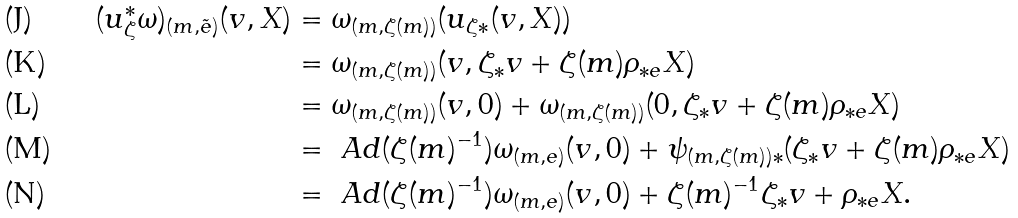<formula> <loc_0><loc_0><loc_500><loc_500>( u _ { \zeta } ^ { * } \omega ) _ { ( m , \tilde { e } ) } ( v , X ) & = \omega _ { ( m , \zeta ( m ) ) } ( u _ { \zeta * } ( v , X ) ) \\ & = \omega _ { ( m , \zeta ( m ) ) } ( v , \zeta _ { * } v + \zeta ( m ) \rho _ { * e } X ) \\ & = \omega _ { ( m , \zeta ( m ) ) } ( v , 0 ) + \omega _ { ( m , \zeta ( m ) ) } ( 0 , \zeta _ { * } v + \zeta ( m ) \rho _ { * e } X ) \\ & = \ A d ( \zeta ( m ) ^ { - 1 } ) \omega _ { ( m , e ) } ( v , 0 ) + \psi _ { ( m , \zeta ( m ) ) * } ( \zeta _ { * } v + \zeta ( m ) \rho _ { * e } X ) \\ & = \ A d ( \zeta ( m ) ^ { - 1 } ) \omega _ { ( m , e ) } ( v , 0 ) + \zeta ( m ) ^ { - 1 } \zeta _ { * } v + \rho _ { * e } X .</formula> 